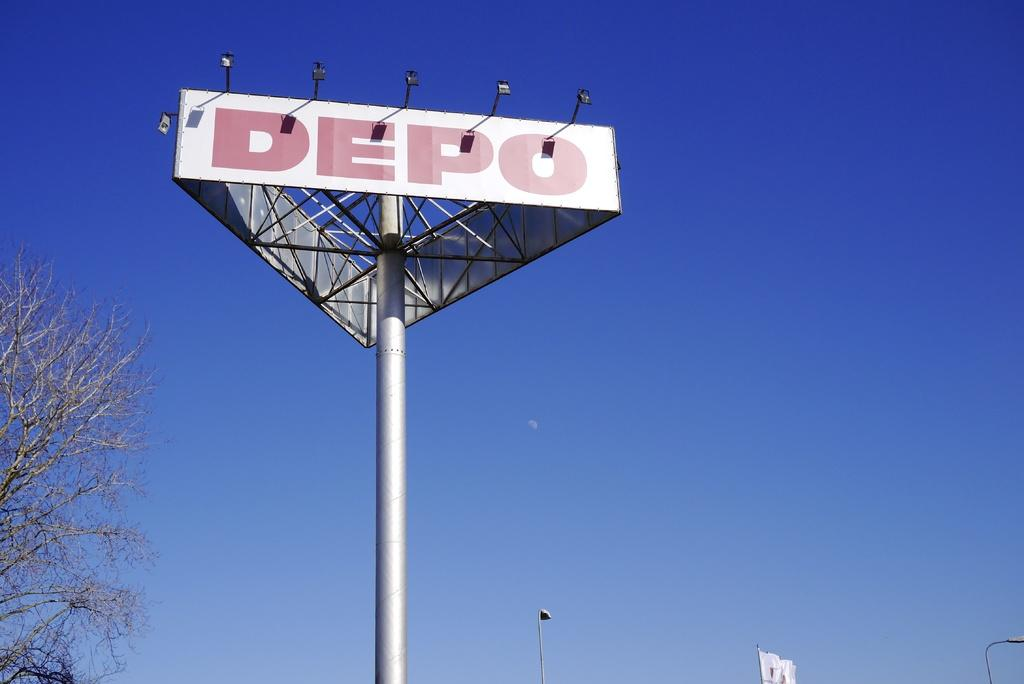<image>
Render a clear and concise summary of the photo. A sign high in the sky against a blue sky with a tree and the sign says DEPO 